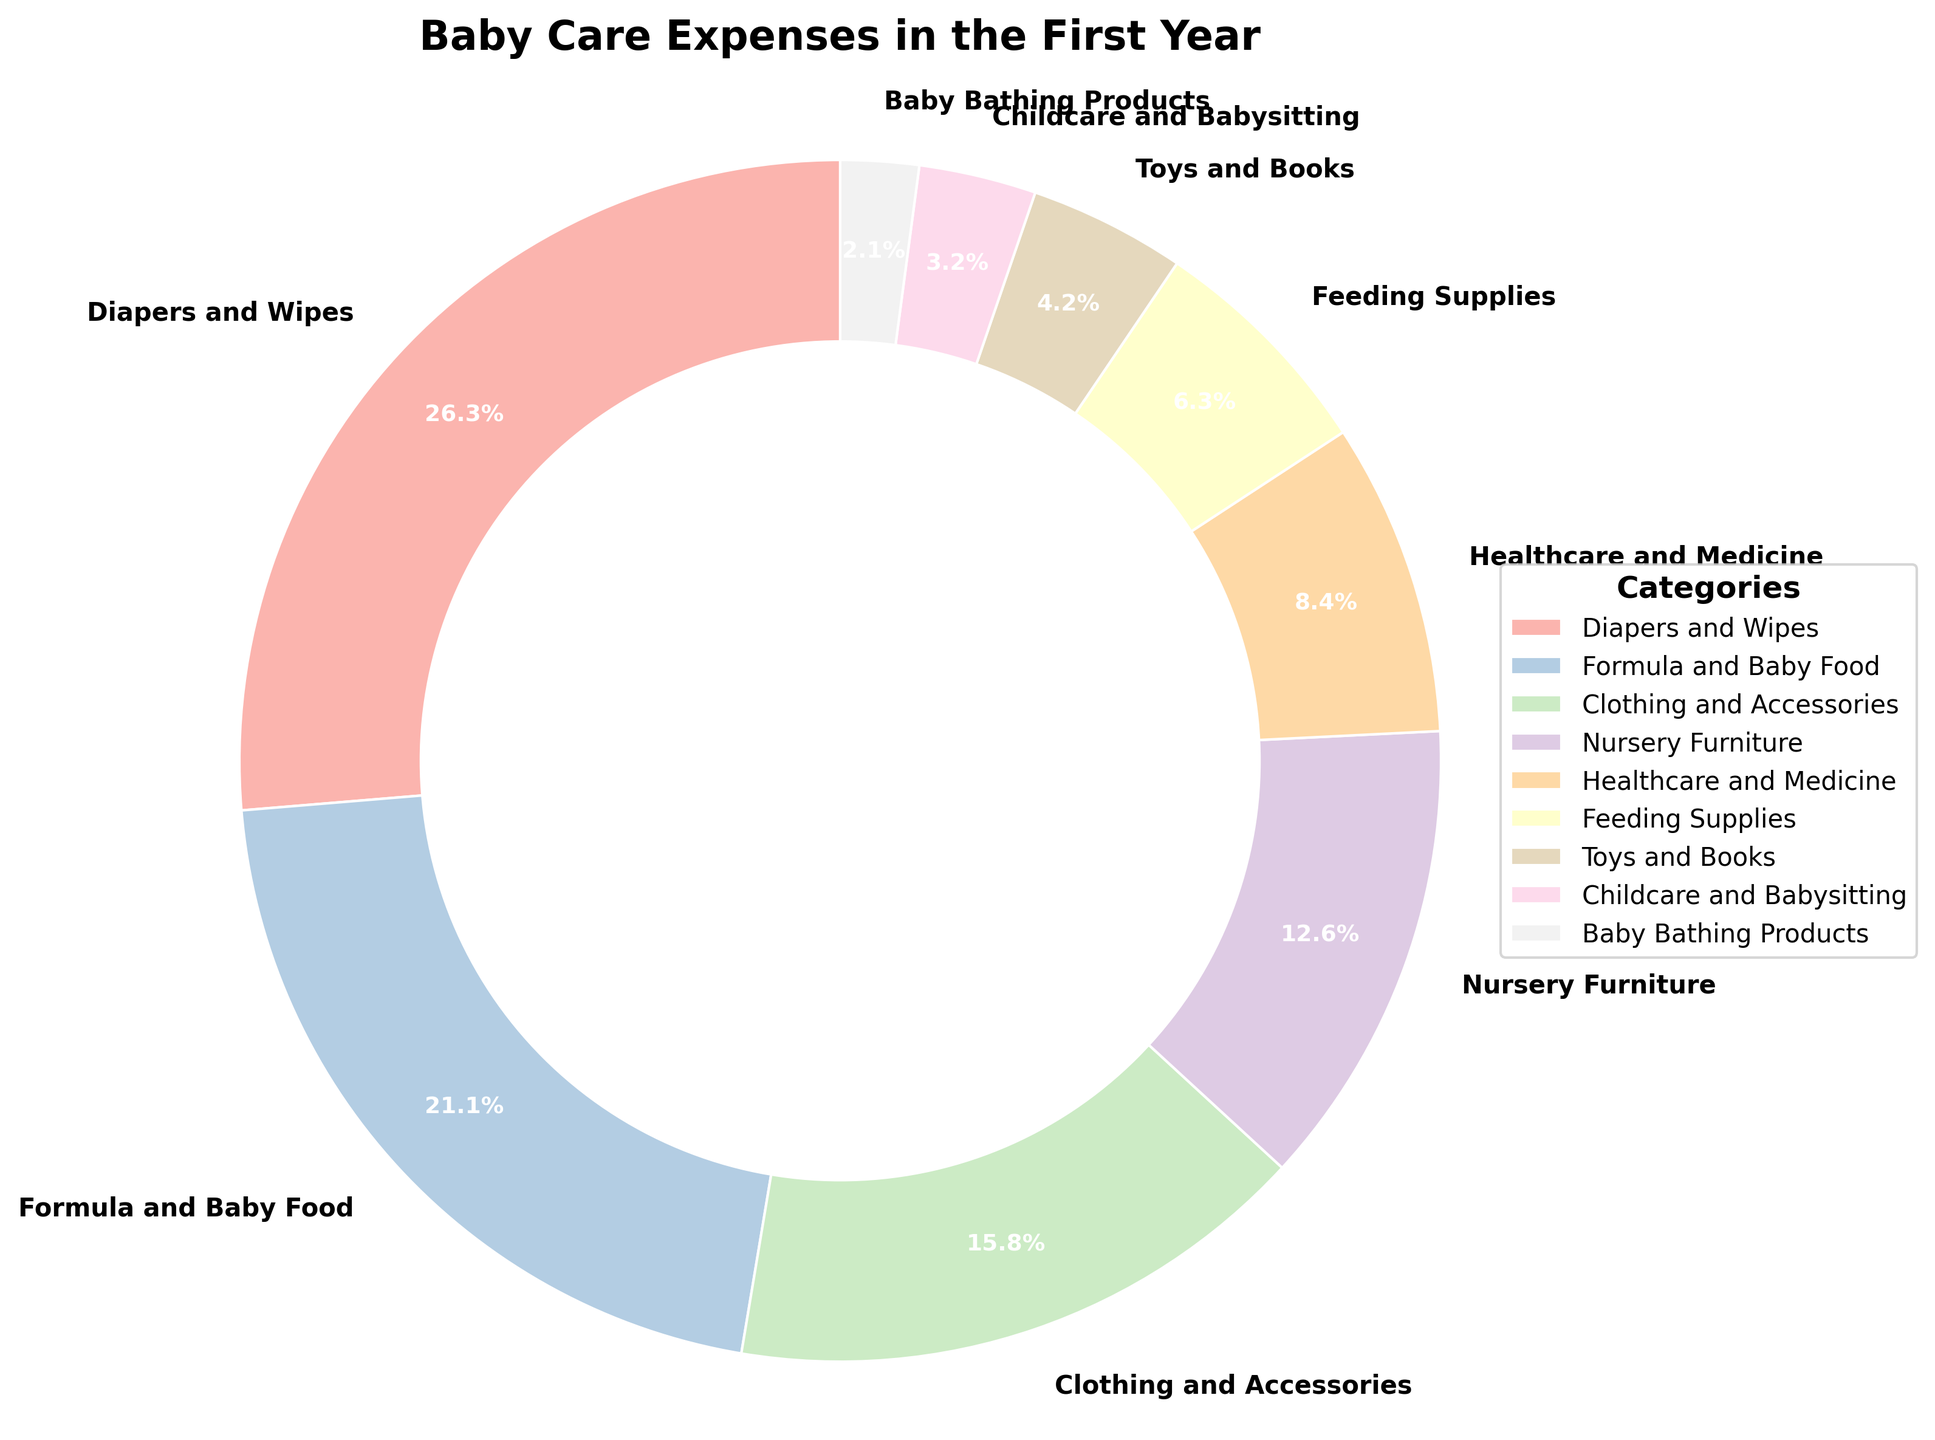Which category constitutes the largest portion of baby care expenses? Look at the pie chart and identify the largest wedge. The largest portion is represented by the 'Diapers and Wipes' section with 25%.
Answer: Diapers and Wipes What percentage of the baby care budget is spent on healthcare and medicine? Find the wedge labeled 'Healthcare and Medicine' and read the percentage indicated. It shows 8%.
Answer: 8% How do the combined expenses on Formula and Baby Food and Clothing and Accessories compare to the expenses on Diapers and Wipes? Add the percentages for Formula and Baby Food (20%) and Clothing and Accessories (15%), which totals 35%. Compare this to Diapers and Wipes (25%). 35% is greater than 25%.
Answer: Greater Which expenses are smaller than 10%? Look at all wedges and note their percentages. Categories with percentages smaller than 10% are Healthcare and Medicine (8%), Feeding Supplies (6%), Toys and Books (4%), Childcare and Babysitting (3%), and Baby Bathing Products (2%).
Answer: Healthcare and Medicine, Feeding Supplies, Toys and Books, Childcare and Babysitting, Baby Bathing Products What is the total percentage spent on Nursery Furniture, Healthcare and Medicine, and Feeding Supplies? Sum the percentages of Nursery Furniture (12%), Healthcare and Medicine (8%), and Feeding Supplies (6%). 12% + 8% + 6% = 26%.
Answer: 26% How does the expense on Feeding Supplies compare to the expense on Toys and Books? Look at both the wedges and compare their percentages. Feeding Supplies is 6% and Toys and Books is 4%. 6% is greater than 4%.
Answer: Greater Between Nursery Furniture and Clothing and Accessories, which has a higher expense? Compare the wedges labeled 'Nursery Furniture' (12%) and 'Clothing and Accessories' (15%). Clothing and Accessories has a higher percentage.
Answer: Clothing and Accessories What combined expenses do all categories below 5% constitute in total? Sum the percentages of Toys and Books (4%), Childcare and Babysitting (3%), and Baby Bathing Products (2%). 4% + 3% + 2% = 9%.
Answer: 9% How much more is spent on Formula and Baby Food than on Healthcare and Medicine? Subtract the percentage of Healthcare and Medicine (8%) from Formula and Baby Food (20%). 20% - 8% = 12%.
Answer: 12% Which category covers a quarter of the total baby care expenses? Find the category that has 25%. The 'Diapers and Wipes' section constitutes one-fourth, or 25%, of the total expenses.
Answer: Diapers and Wipes 